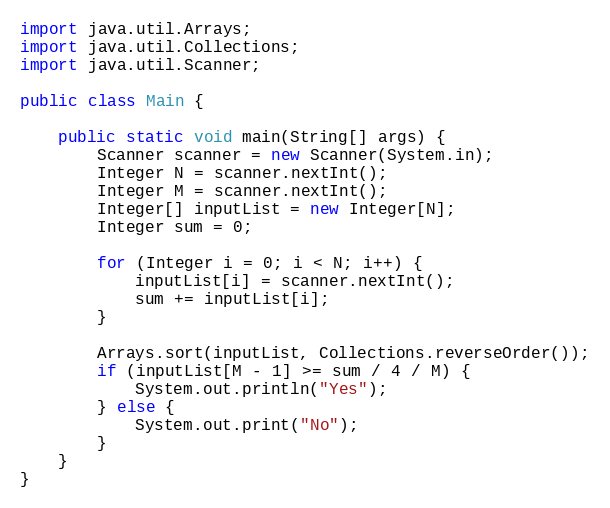Convert code to text. <code><loc_0><loc_0><loc_500><loc_500><_Java_>import java.util.Arrays;
import java.util.Collections;
import java.util.Scanner;

public class Main {

    public static void main(String[] args) {
        Scanner scanner = new Scanner(System.in);
        Integer N = scanner.nextInt();
        Integer M = scanner.nextInt();
        Integer[] inputList = new Integer[N];
        Integer sum = 0;

        for (Integer i = 0; i < N; i++) {
            inputList[i] = scanner.nextInt();
            sum += inputList[i];
        }
      
        Arrays.sort(inputList, Collections.reverseOrder());
        if (inputList[M - 1] >= sum / 4 / M) {
            System.out.println("Yes");
        } else {
            System.out.print("No");
        }
    }
}</code> 